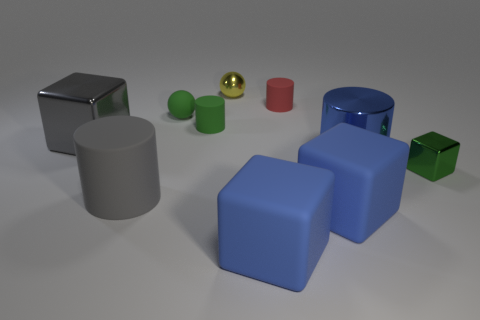Subtract all blue spheres. How many blue cubes are left? 2 Subtract all blue shiny cylinders. How many cylinders are left? 3 Subtract all gray blocks. How many blocks are left? 3 Subtract 2 blocks. How many blocks are left? 2 Subtract all spheres. How many objects are left? 8 Subtract all purple blocks. Subtract all green cylinders. How many blocks are left? 4 Add 3 large gray cubes. How many large gray cubes exist? 4 Subtract 0 brown cubes. How many objects are left? 10 Subtract all small cylinders. Subtract all small yellow metallic spheres. How many objects are left? 7 Add 5 green matte objects. How many green matte objects are left? 7 